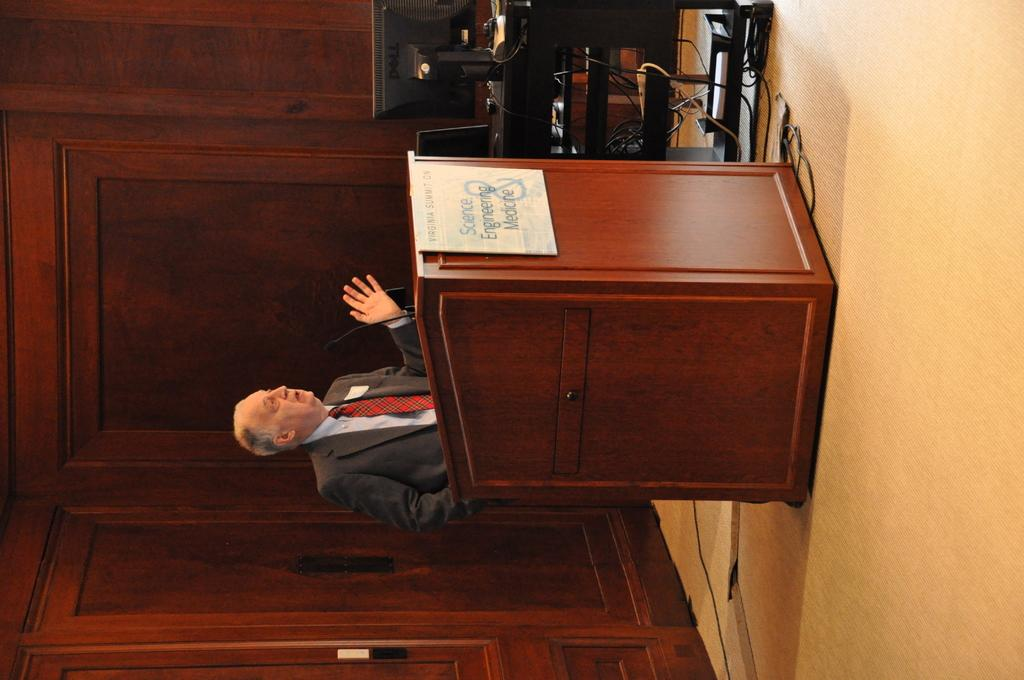What is the main object in the image? There is a podium in the image. Who is standing near the podium? A man is standing behind the podium. What can be seen in the background of the image? There is a monitor and a wooden wall in the background of the image. What type of muscle is being flexed by the man in the image? There is no indication of muscle flexing in the image. 